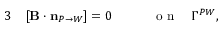Convert formula to latex. <formula><loc_0><loc_0><loc_500><loc_500>\begin{array} { r l r } { 3 } & [ { \mathbf B } \cdot n _ { P \rightarrow W } ] = 0 \quad } & { o n \quad \Gamma ^ { P W } , } \end{array}</formula> 